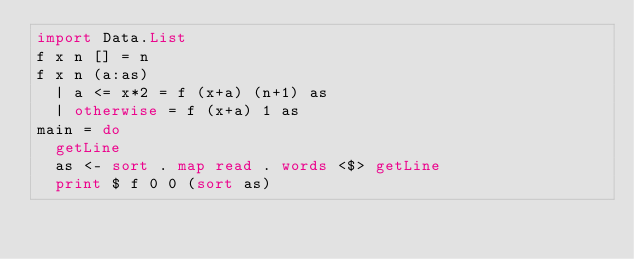Convert code to text. <code><loc_0><loc_0><loc_500><loc_500><_Haskell_>import Data.List
f x n [] = n
f x n (a:as)
  | a <= x*2 = f (x+a) (n+1) as
  | otherwise = f (x+a) 1 as
main = do
  getLine
  as <- sort . map read . words <$> getLine
  print $ f 0 0 (sort as)</code> 